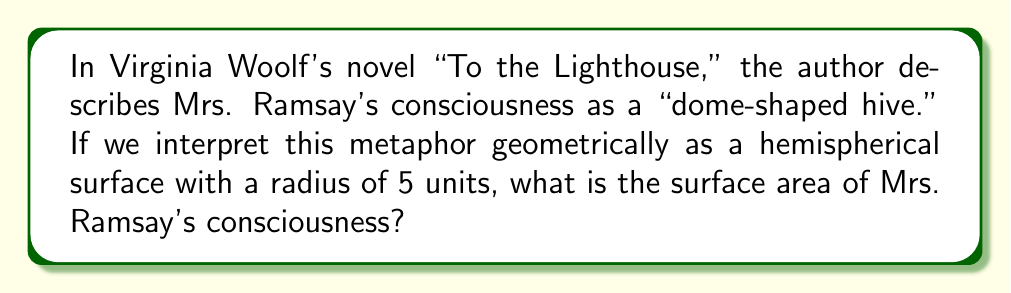Show me your answer to this math problem. To solve this problem, we'll interpret the "dome-shaped hive" as a hemisphere and calculate its surface area. Let's approach this step-by-step:

1. Recall the formula for the surface area of a sphere:
   $$A_{sphere} = 4\pi r^2$$

2. A hemisphere is half of a sphere, but we need to include the circular base. The formula for the surface area of a hemisphere is:
   $$A_{hemisphere} = 2\pi r^2 + \pi r^2 = 3\pi r^2$$

3. We're given that the radius is 5 units. Let's substitute this into our formula:
   $$A_{hemisphere} = 3\pi (5)^2$$

4. Simplify:
   $$A_{hemisphere} = 3\pi (25) = 75\pi$$

5. If we want to express this in terms of square units:
   $$A_{hemisphere} = 75\pi \text{ square units}$$

This result represents the surface area of Mrs. Ramsay's consciousness as metaphorically described in the novel.
Answer: $75\pi$ square units 